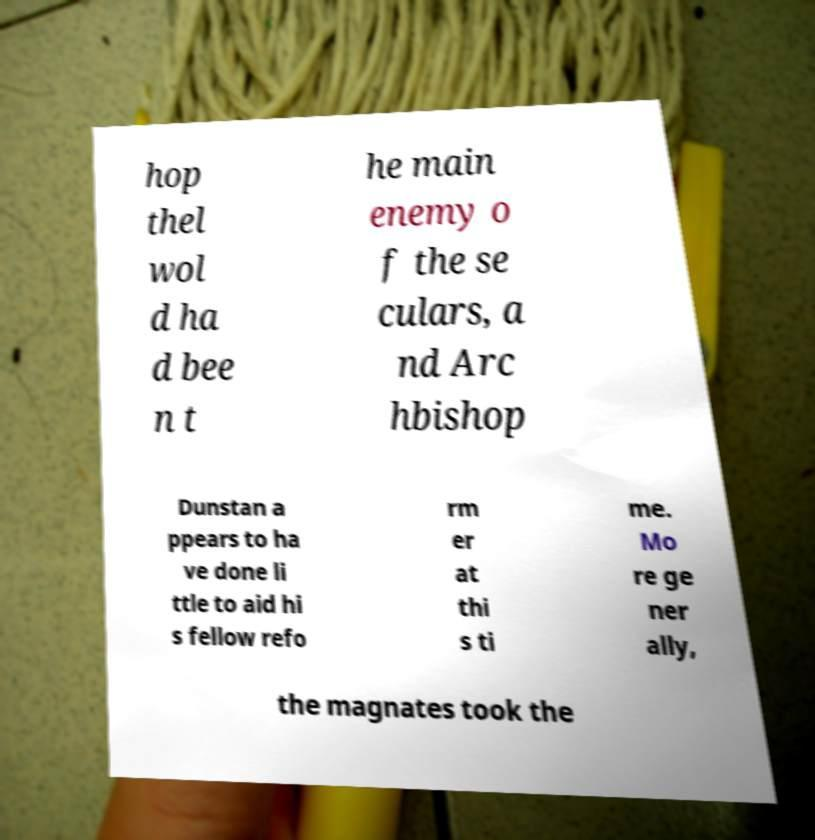For documentation purposes, I need the text within this image transcribed. Could you provide that? hop thel wol d ha d bee n t he main enemy o f the se culars, a nd Arc hbishop Dunstan a ppears to ha ve done li ttle to aid hi s fellow refo rm er at thi s ti me. Mo re ge ner ally, the magnates took the 